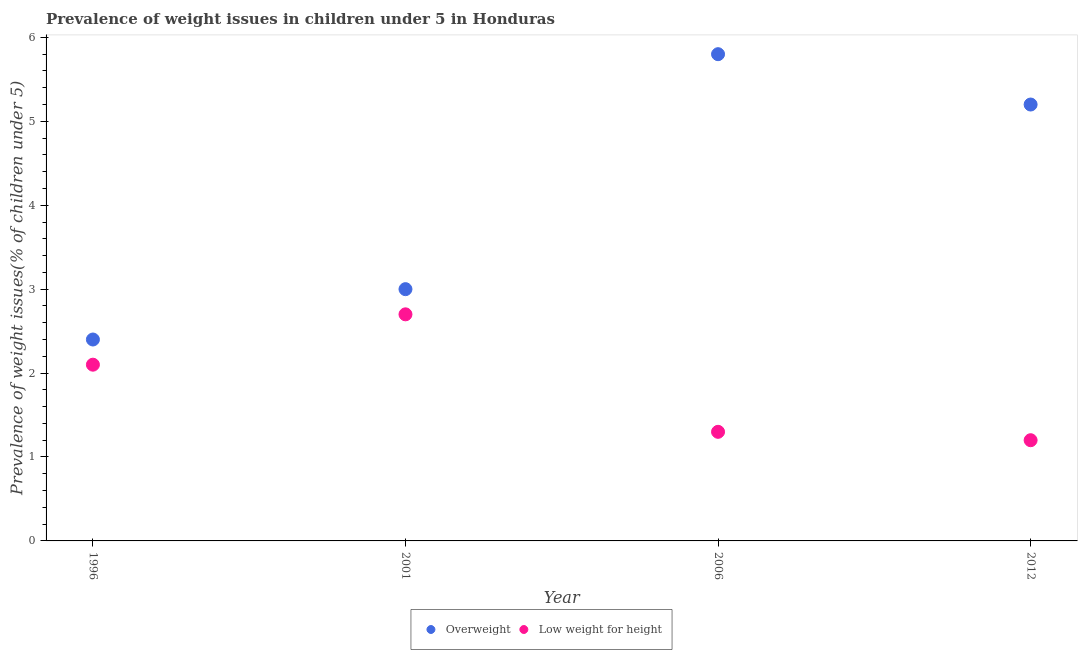How many different coloured dotlines are there?
Your response must be concise. 2. Is the number of dotlines equal to the number of legend labels?
Ensure brevity in your answer.  Yes. What is the percentage of overweight children in 2012?
Provide a succinct answer. 5.2. Across all years, what is the maximum percentage of overweight children?
Provide a short and direct response. 5.8. Across all years, what is the minimum percentage of underweight children?
Offer a very short reply. 1.2. In which year was the percentage of overweight children maximum?
Give a very brief answer. 2006. In which year was the percentage of overweight children minimum?
Your response must be concise. 1996. What is the total percentage of overweight children in the graph?
Offer a very short reply. 16.4. What is the difference between the percentage of overweight children in 2001 and that in 2012?
Make the answer very short. -2.2. What is the difference between the percentage of underweight children in 2012 and the percentage of overweight children in 1996?
Your answer should be compact. -1.2. What is the average percentage of underweight children per year?
Your response must be concise. 1.82. In the year 2006, what is the difference between the percentage of overweight children and percentage of underweight children?
Offer a very short reply. 4.5. In how many years, is the percentage of overweight children greater than 1 %?
Provide a succinct answer. 4. What is the ratio of the percentage of overweight children in 2006 to that in 2012?
Your answer should be very brief. 1.12. Is the percentage of overweight children in 2006 less than that in 2012?
Keep it short and to the point. No. Is the difference between the percentage of overweight children in 1996 and 2006 greater than the difference between the percentage of underweight children in 1996 and 2006?
Provide a short and direct response. No. What is the difference between the highest and the second highest percentage of overweight children?
Offer a terse response. 0.6. What is the difference between the highest and the lowest percentage of overweight children?
Offer a terse response. 3.4. Is the percentage of underweight children strictly greater than the percentage of overweight children over the years?
Give a very brief answer. No. Is the percentage of overweight children strictly less than the percentage of underweight children over the years?
Give a very brief answer. No. What is the difference between two consecutive major ticks on the Y-axis?
Offer a very short reply. 1. Does the graph contain any zero values?
Your answer should be very brief. No. Where does the legend appear in the graph?
Provide a short and direct response. Bottom center. How are the legend labels stacked?
Make the answer very short. Horizontal. What is the title of the graph?
Offer a very short reply. Prevalence of weight issues in children under 5 in Honduras. What is the label or title of the X-axis?
Your answer should be compact. Year. What is the label or title of the Y-axis?
Your answer should be compact. Prevalence of weight issues(% of children under 5). What is the Prevalence of weight issues(% of children under 5) in Overweight in 1996?
Your response must be concise. 2.4. What is the Prevalence of weight issues(% of children under 5) of Low weight for height in 1996?
Your response must be concise. 2.1. What is the Prevalence of weight issues(% of children under 5) of Overweight in 2001?
Your response must be concise. 3. What is the Prevalence of weight issues(% of children under 5) in Low weight for height in 2001?
Give a very brief answer. 2.7. What is the Prevalence of weight issues(% of children under 5) in Overweight in 2006?
Your response must be concise. 5.8. What is the Prevalence of weight issues(% of children under 5) of Low weight for height in 2006?
Your response must be concise. 1.3. What is the Prevalence of weight issues(% of children under 5) of Overweight in 2012?
Your answer should be compact. 5.2. What is the Prevalence of weight issues(% of children under 5) of Low weight for height in 2012?
Your response must be concise. 1.2. Across all years, what is the maximum Prevalence of weight issues(% of children under 5) in Overweight?
Offer a very short reply. 5.8. Across all years, what is the maximum Prevalence of weight issues(% of children under 5) in Low weight for height?
Provide a succinct answer. 2.7. Across all years, what is the minimum Prevalence of weight issues(% of children under 5) of Overweight?
Give a very brief answer. 2.4. Across all years, what is the minimum Prevalence of weight issues(% of children under 5) in Low weight for height?
Keep it short and to the point. 1.2. What is the total Prevalence of weight issues(% of children under 5) in Overweight in the graph?
Ensure brevity in your answer.  16.4. What is the difference between the Prevalence of weight issues(% of children under 5) of Overweight in 1996 and that in 2006?
Give a very brief answer. -3.4. What is the difference between the Prevalence of weight issues(% of children under 5) in Overweight in 1996 and that in 2012?
Provide a succinct answer. -2.8. What is the difference between the Prevalence of weight issues(% of children under 5) in Low weight for height in 1996 and that in 2012?
Your answer should be very brief. 0.9. What is the difference between the Prevalence of weight issues(% of children under 5) of Low weight for height in 2001 and that in 2006?
Your answer should be compact. 1.4. What is the difference between the Prevalence of weight issues(% of children under 5) of Overweight in 2001 and that in 2012?
Offer a terse response. -2.2. What is the difference between the Prevalence of weight issues(% of children under 5) of Overweight in 2001 and the Prevalence of weight issues(% of children under 5) of Low weight for height in 2006?
Ensure brevity in your answer.  1.7. What is the difference between the Prevalence of weight issues(% of children under 5) of Overweight in 2006 and the Prevalence of weight issues(% of children under 5) of Low weight for height in 2012?
Offer a very short reply. 4.6. What is the average Prevalence of weight issues(% of children under 5) in Low weight for height per year?
Make the answer very short. 1.82. In the year 2006, what is the difference between the Prevalence of weight issues(% of children under 5) of Overweight and Prevalence of weight issues(% of children under 5) of Low weight for height?
Your answer should be compact. 4.5. In the year 2012, what is the difference between the Prevalence of weight issues(% of children under 5) of Overweight and Prevalence of weight issues(% of children under 5) of Low weight for height?
Your answer should be very brief. 4. What is the ratio of the Prevalence of weight issues(% of children under 5) in Low weight for height in 1996 to that in 2001?
Offer a very short reply. 0.78. What is the ratio of the Prevalence of weight issues(% of children under 5) of Overweight in 1996 to that in 2006?
Your response must be concise. 0.41. What is the ratio of the Prevalence of weight issues(% of children under 5) in Low weight for height in 1996 to that in 2006?
Provide a short and direct response. 1.62. What is the ratio of the Prevalence of weight issues(% of children under 5) in Overweight in 1996 to that in 2012?
Your answer should be compact. 0.46. What is the ratio of the Prevalence of weight issues(% of children under 5) of Low weight for height in 1996 to that in 2012?
Give a very brief answer. 1.75. What is the ratio of the Prevalence of weight issues(% of children under 5) in Overweight in 2001 to that in 2006?
Your answer should be very brief. 0.52. What is the ratio of the Prevalence of weight issues(% of children under 5) in Low weight for height in 2001 to that in 2006?
Offer a terse response. 2.08. What is the ratio of the Prevalence of weight issues(% of children under 5) of Overweight in 2001 to that in 2012?
Make the answer very short. 0.58. What is the ratio of the Prevalence of weight issues(% of children under 5) of Low weight for height in 2001 to that in 2012?
Offer a very short reply. 2.25. What is the ratio of the Prevalence of weight issues(% of children under 5) of Overweight in 2006 to that in 2012?
Your response must be concise. 1.12. What is the ratio of the Prevalence of weight issues(% of children under 5) in Low weight for height in 2006 to that in 2012?
Your answer should be very brief. 1.08. What is the difference between the highest and the second highest Prevalence of weight issues(% of children under 5) in Overweight?
Make the answer very short. 0.6. What is the difference between the highest and the second highest Prevalence of weight issues(% of children under 5) in Low weight for height?
Your answer should be compact. 0.6. 